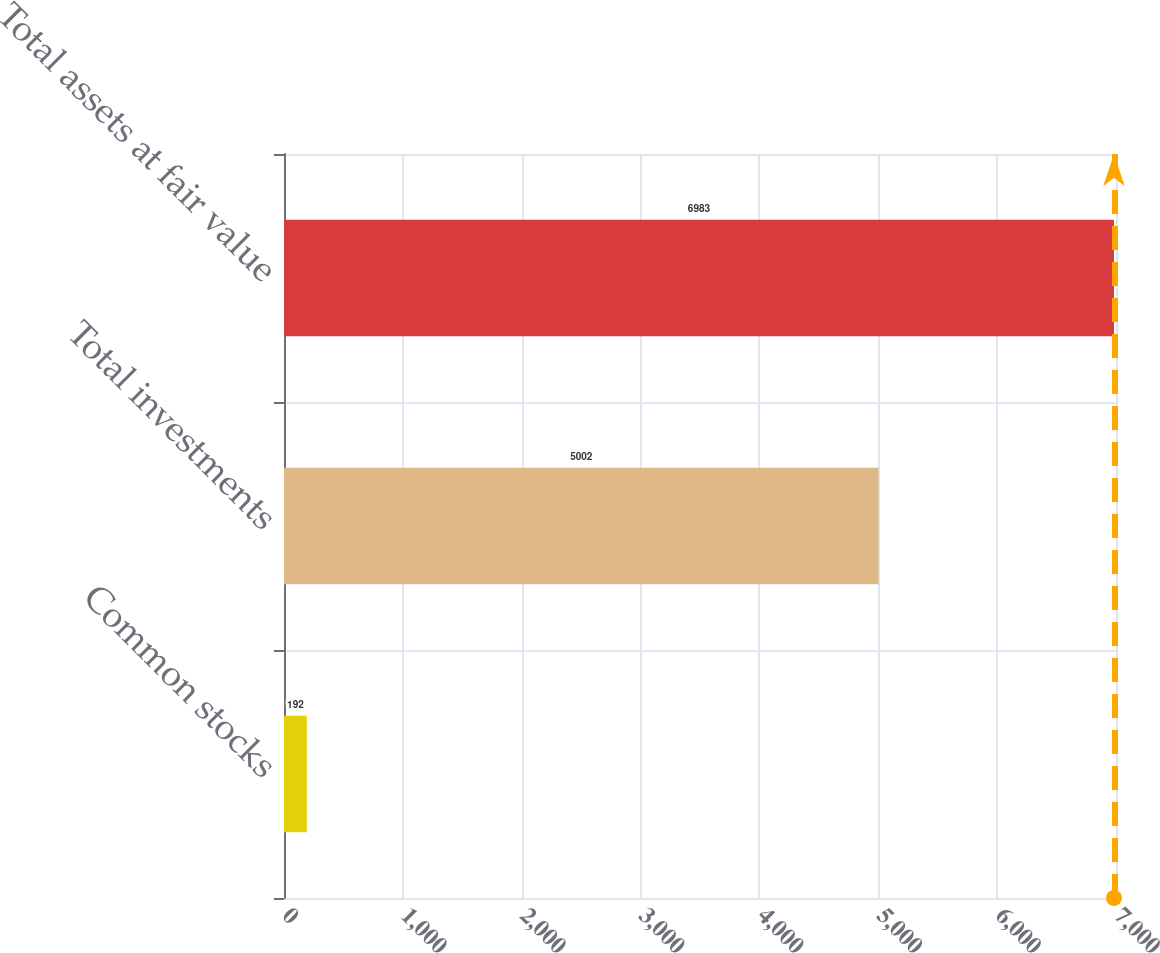Convert chart to OTSL. <chart><loc_0><loc_0><loc_500><loc_500><bar_chart><fcel>Common stocks<fcel>Total investments<fcel>Total assets at fair value<nl><fcel>192<fcel>5002<fcel>6983<nl></chart> 